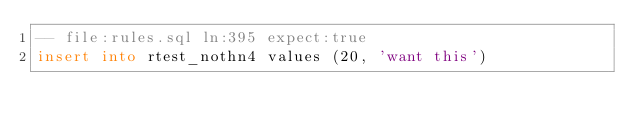<code> <loc_0><loc_0><loc_500><loc_500><_SQL_>-- file:rules.sql ln:395 expect:true
insert into rtest_nothn4 values (20, 'want this')
</code> 